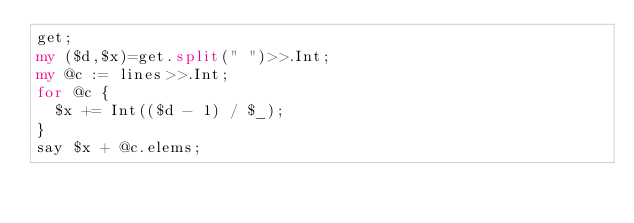Convert code to text. <code><loc_0><loc_0><loc_500><loc_500><_Perl_>get;
my ($d,$x)=get.split(" ")>>.Int;
my @c := lines>>.Int;
for @c {
  $x += Int(($d - 1) / $_);
}
say $x + @c.elems;</code> 